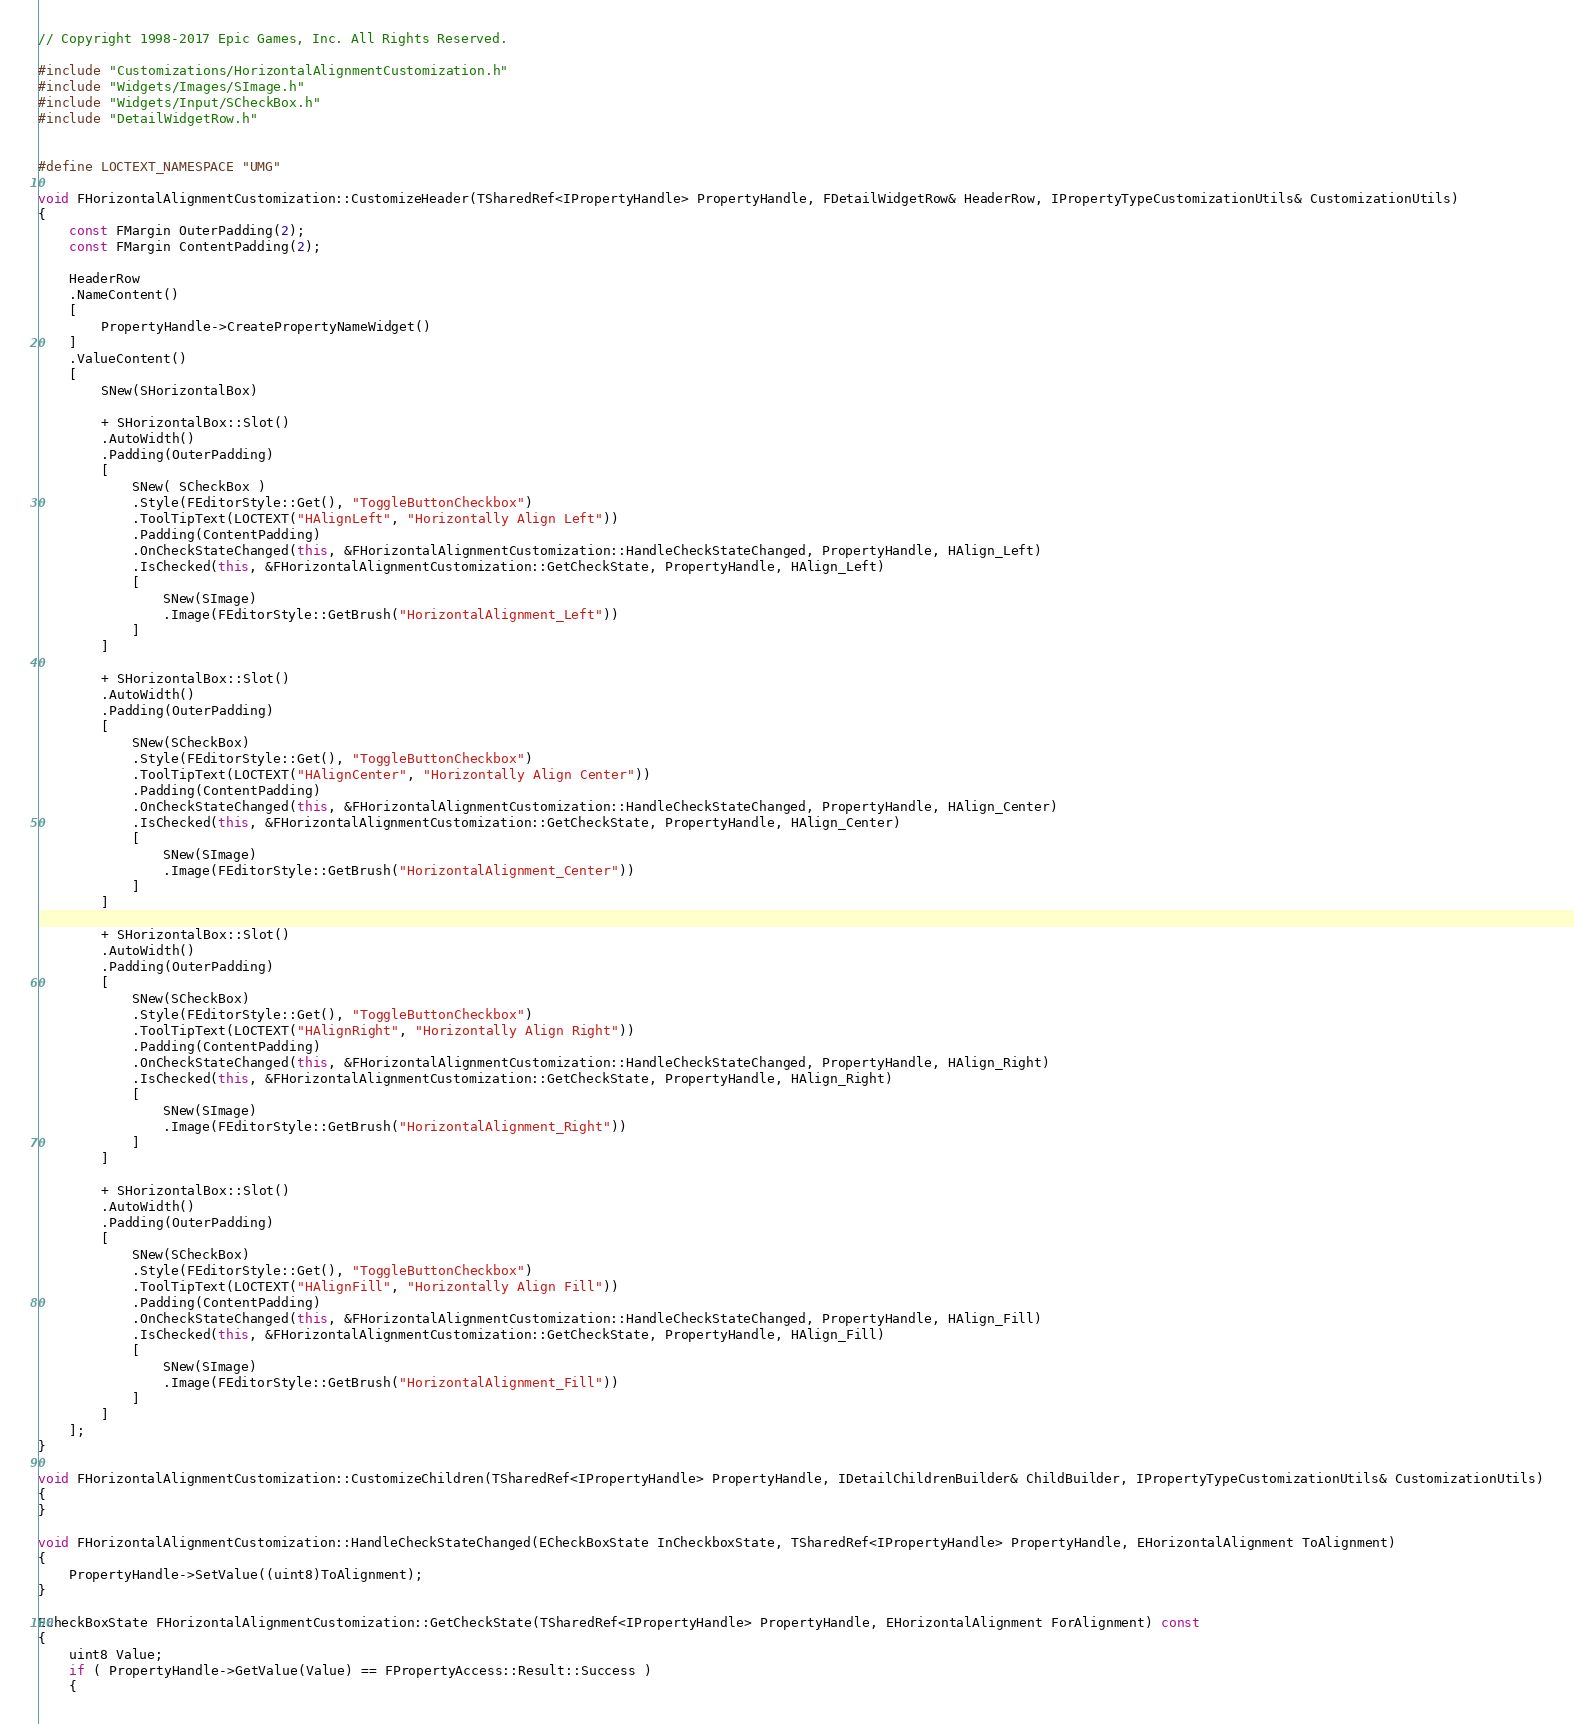Convert code to text. <code><loc_0><loc_0><loc_500><loc_500><_C++_>// Copyright 1998-2017 Epic Games, Inc. All Rights Reserved.

#include "Customizations/HorizontalAlignmentCustomization.h"
#include "Widgets/Images/SImage.h"
#include "Widgets/Input/SCheckBox.h"
#include "DetailWidgetRow.h"


#define LOCTEXT_NAMESPACE "UMG"

void FHorizontalAlignmentCustomization::CustomizeHeader(TSharedRef<IPropertyHandle> PropertyHandle, FDetailWidgetRow& HeaderRow, IPropertyTypeCustomizationUtils& CustomizationUtils)
{
	const FMargin OuterPadding(2);
	const FMargin ContentPadding(2);

	HeaderRow
	.NameContent()
	[
		PropertyHandle->CreatePropertyNameWidget()
	]
	.ValueContent()
	[
		SNew(SHorizontalBox)

		+ SHorizontalBox::Slot()
		.AutoWidth()
		.Padding(OuterPadding)
		[
			SNew( SCheckBox )
			.Style(FEditorStyle::Get(), "ToggleButtonCheckbox")
			.ToolTipText(LOCTEXT("HAlignLeft", "Horizontally Align Left"))
			.Padding(ContentPadding)
			.OnCheckStateChanged(this, &FHorizontalAlignmentCustomization::HandleCheckStateChanged, PropertyHandle, HAlign_Left)
			.IsChecked(this, &FHorizontalAlignmentCustomization::GetCheckState, PropertyHandle, HAlign_Left)
			[
				SNew(SImage)
				.Image(FEditorStyle::GetBrush("HorizontalAlignment_Left"))
			]
		]

		+ SHorizontalBox::Slot()
		.AutoWidth()
		.Padding(OuterPadding)
		[
			SNew(SCheckBox)
			.Style(FEditorStyle::Get(), "ToggleButtonCheckbox")
			.ToolTipText(LOCTEXT("HAlignCenter", "Horizontally Align Center"))
			.Padding(ContentPadding)
			.OnCheckStateChanged(this, &FHorizontalAlignmentCustomization::HandleCheckStateChanged, PropertyHandle, HAlign_Center)
			.IsChecked(this, &FHorizontalAlignmentCustomization::GetCheckState, PropertyHandle, HAlign_Center)
			[
				SNew(SImage)
				.Image(FEditorStyle::GetBrush("HorizontalAlignment_Center"))
			]
		]

		+ SHorizontalBox::Slot()
		.AutoWidth()
		.Padding(OuterPadding)
		[
			SNew(SCheckBox)
			.Style(FEditorStyle::Get(), "ToggleButtonCheckbox")
			.ToolTipText(LOCTEXT("HAlignRight", "Horizontally Align Right"))
			.Padding(ContentPadding)
			.OnCheckStateChanged(this, &FHorizontalAlignmentCustomization::HandleCheckStateChanged, PropertyHandle, HAlign_Right)
			.IsChecked(this, &FHorizontalAlignmentCustomization::GetCheckState, PropertyHandle, HAlign_Right)
			[
				SNew(SImage)
				.Image(FEditorStyle::GetBrush("HorizontalAlignment_Right"))
			]
		]

		+ SHorizontalBox::Slot()
		.AutoWidth()
		.Padding(OuterPadding)
		[
			SNew(SCheckBox)
			.Style(FEditorStyle::Get(), "ToggleButtonCheckbox")
			.ToolTipText(LOCTEXT("HAlignFill", "Horizontally Align Fill"))
			.Padding(ContentPadding)
			.OnCheckStateChanged(this, &FHorizontalAlignmentCustomization::HandleCheckStateChanged, PropertyHandle, HAlign_Fill)
			.IsChecked(this, &FHorizontalAlignmentCustomization::GetCheckState, PropertyHandle, HAlign_Fill)
			[
				SNew(SImage)
				.Image(FEditorStyle::GetBrush("HorizontalAlignment_Fill"))
			]
		]
	];
}

void FHorizontalAlignmentCustomization::CustomizeChildren(TSharedRef<IPropertyHandle> PropertyHandle, IDetailChildrenBuilder& ChildBuilder, IPropertyTypeCustomizationUtils& CustomizationUtils)
{
}

void FHorizontalAlignmentCustomization::HandleCheckStateChanged(ECheckBoxState InCheckboxState, TSharedRef<IPropertyHandle> PropertyHandle, EHorizontalAlignment ToAlignment)
{
	PropertyHandle->SetValue((uint8)ToAlignment);
}

ECheckBoxState FHorizontalAlignmentCustomization::GetCheckState(TSharedRef<IPropertyHandle> PropertyHandle, EHorizontalAlignment ForAlignment) const
{
	uint8 Value;
	if ( PropertyHandle->GetValue(Value) == FPropertyAccess::Result::Success )
	{</code> 